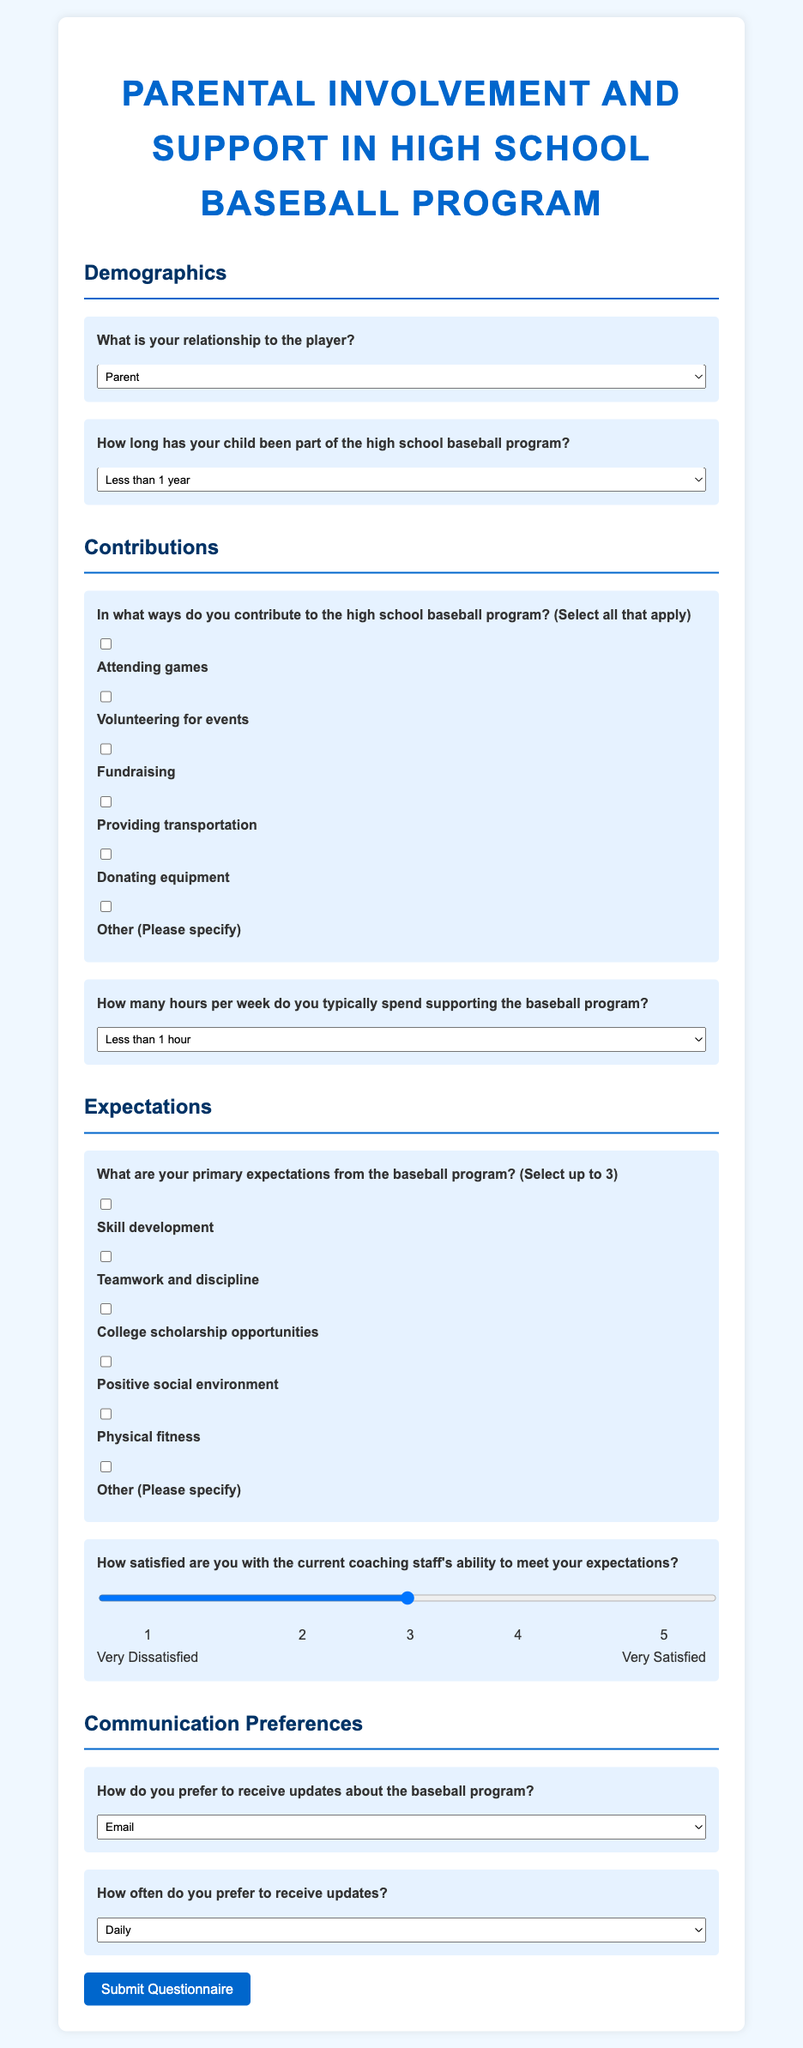What is the title of the questionnaire? The title is found at the top of the document, summarizing the purpose of the questionnaire.
Answer: Parental Involvement and Support in High School Baseball Program What relationship options are provided for the player? The relationship options can be found in the demographics section of the document.
Answer: Parent, Guardian, Relative, Other How long has your child been part of the program? This information can be retrieved from the demographics section, where various time options are given.
Answer: Less than 1 year, 1-2 years, 3-4 years, More than 4 years What are the primary expectations mentioned in the questionnaire? The expectations can be categorized based on the different options listed under the expectations section.
Answer: Skill development, Teamwork and discipline, College scholarship opportunities, Positive social environment, Physical fitness, Other How do you prefer to receive updates about the baseball program? This preference can be found in the communication preferences section of the document, specifying various methods of communication.
Answer: Email, Phone calls, Text messages, Social media, Team meetings What is the rating scale used to measure satisfaction with coaching staff? The range for satisfaction is outlined with specific numbers representing levels of satisfaction.
Answer: 1 to 5 How many hours per week do parents typically spend supporting the program? This question refers to the options provided in the contributions section.
Answer: Less than 1 hour, 1-2 hours, 3-4 hours, More than 4 hours What is the maximum number of expectations a parent can select? The document limits the number of expectations that can be chosen, which can be found in the expectations section.
Answer: 3 Which section follows after contributions? The arrangement of the sections can be followed to understand the order in the questionnaire.
Answer: Expectations What is the color of the background used in the document? The background color can be noted from the document's style information.
Answer: Light blue 